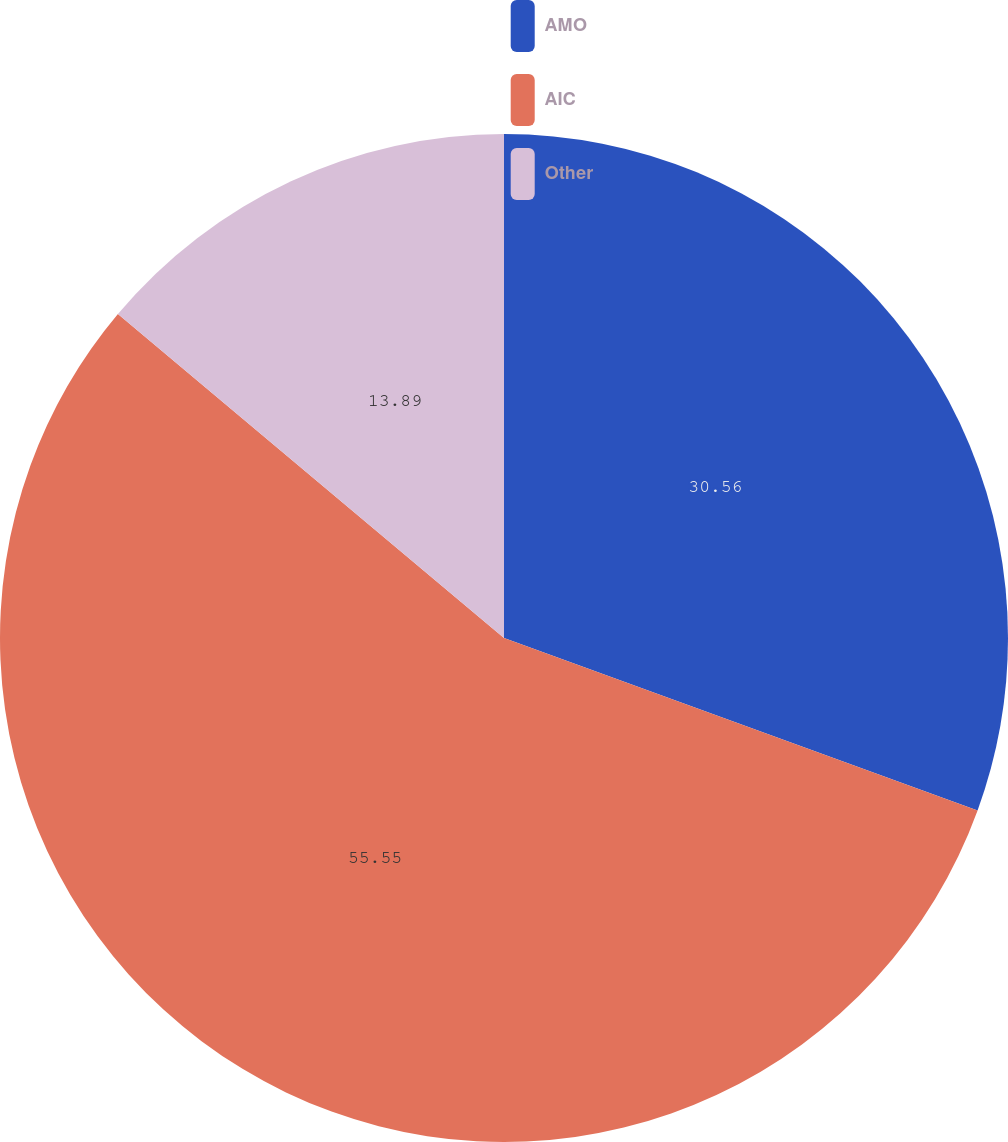<chart> <loc_0><loc_0><loc_500><loc_500><pie_chart><fcel>AMO<fcel>AIC<fcel>Other<nl><fcel>30.56%<fcel>55.56%<fcel>13.89%<nl></chart> 